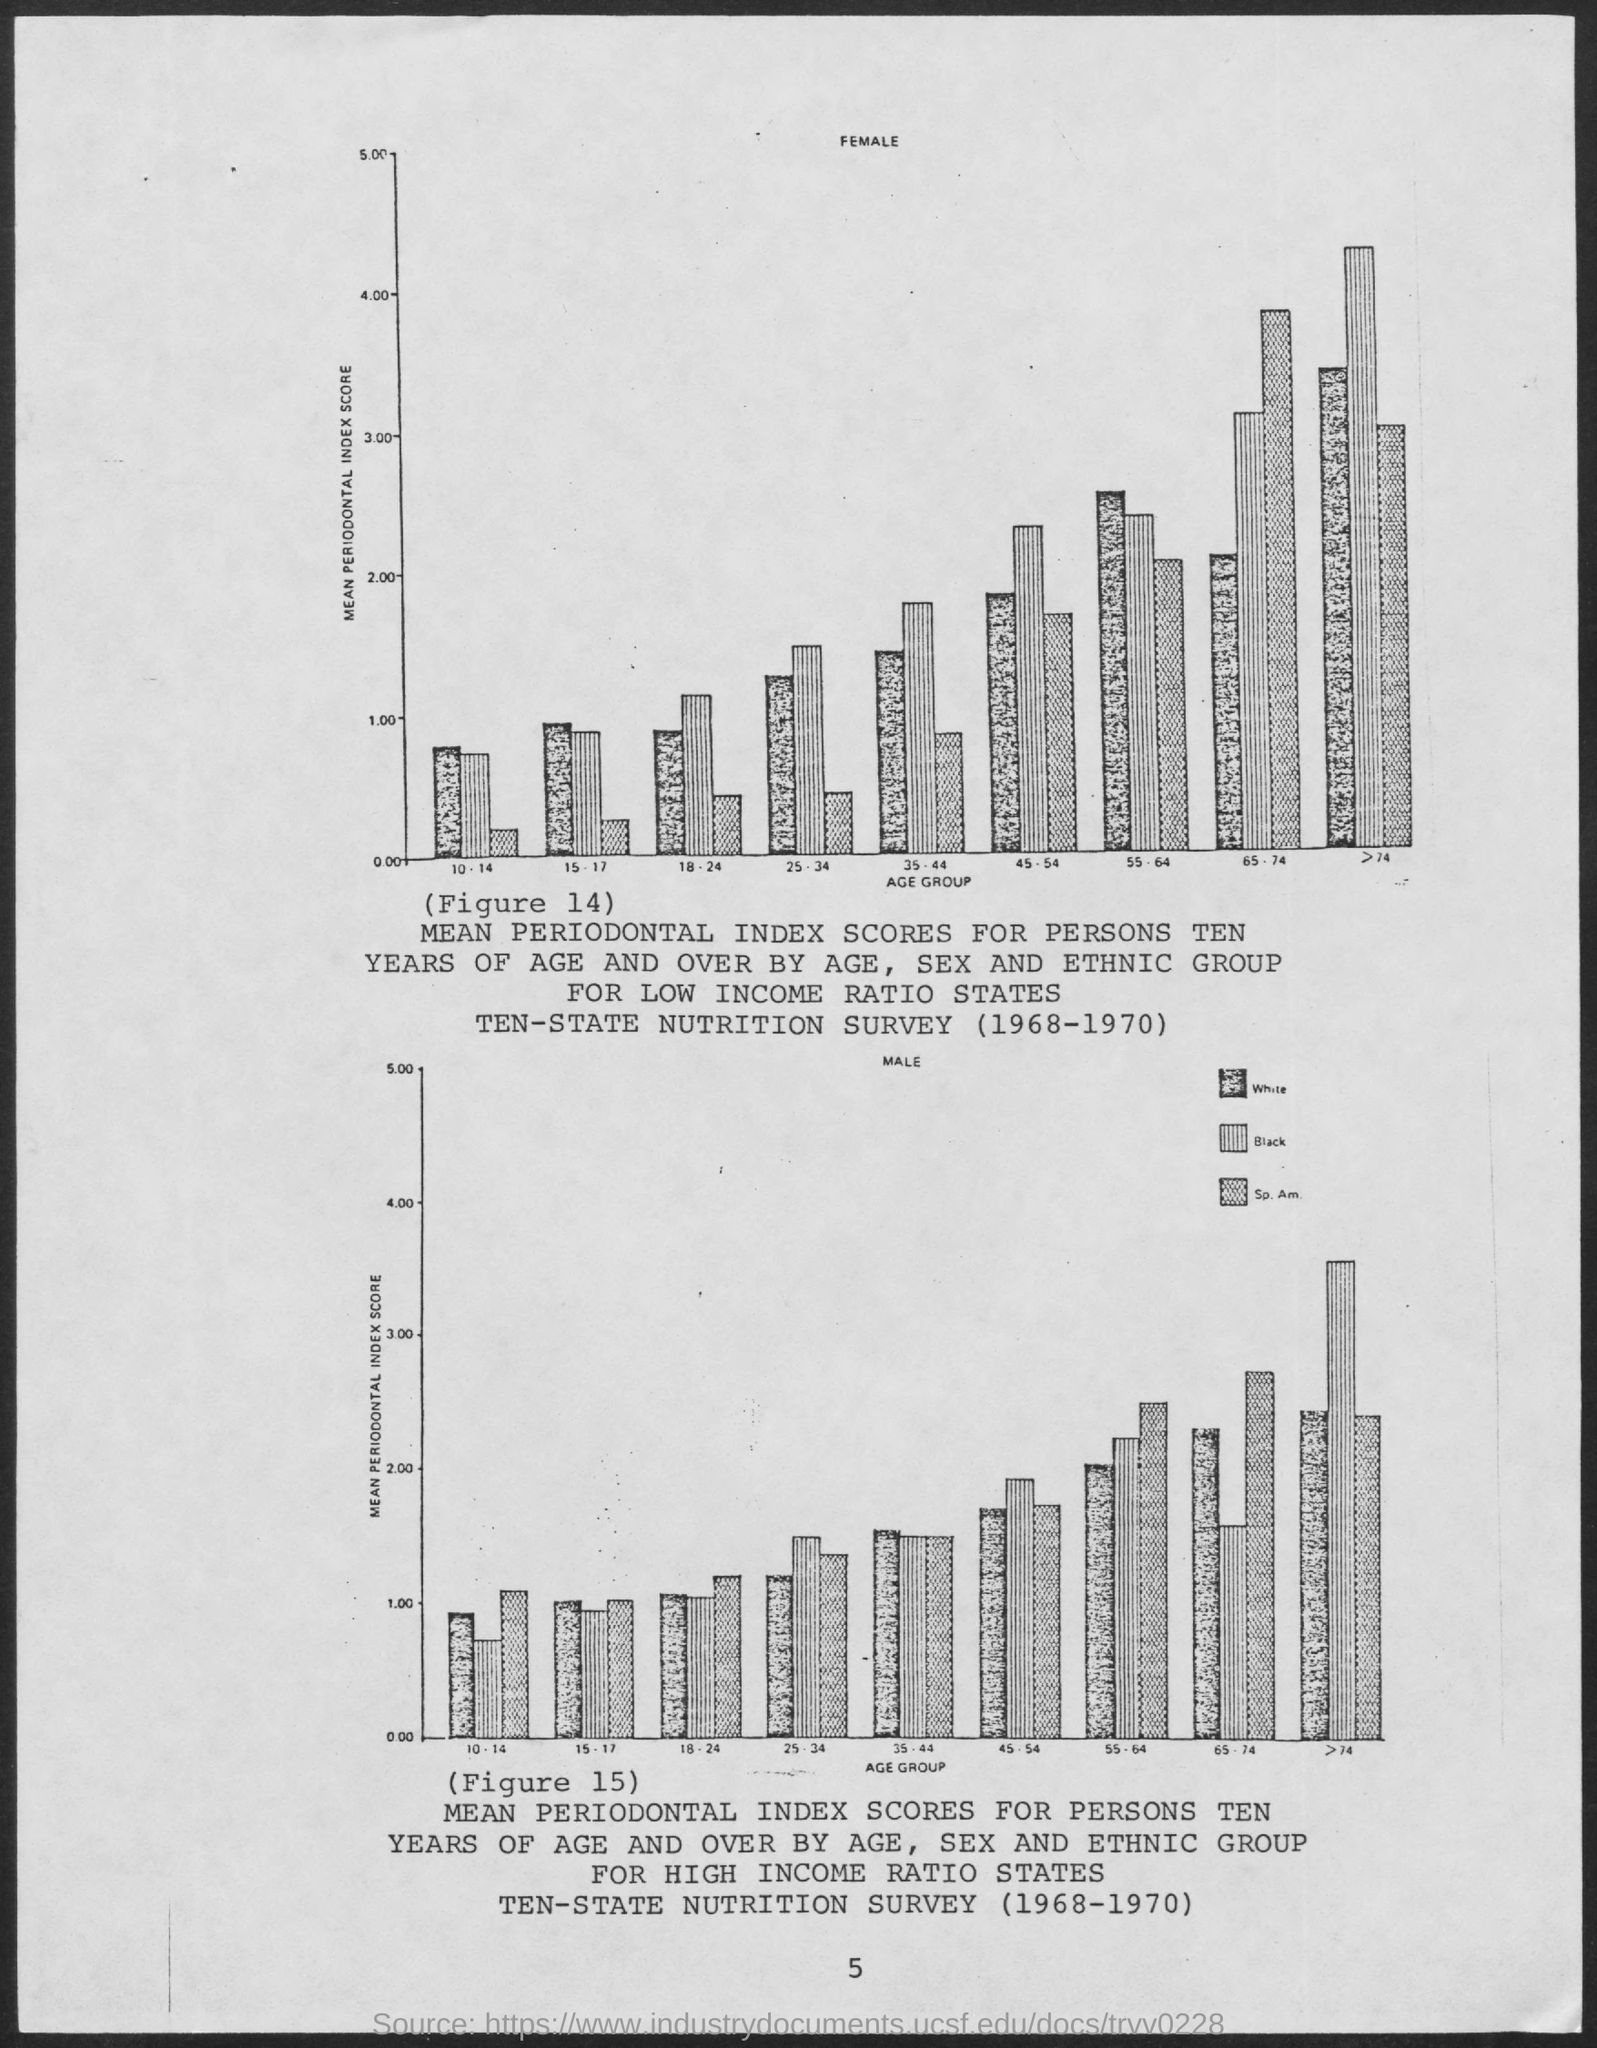What is plotted in the x-axis of both graph?
Provide a short and direct response. Age Group. What is plotted in the y-axis of both graph?
Ensure brevity in your answer.  Mean Periodontal Index Score. 